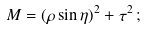Convert formula to latex. <formula><loc_0><loc_0><loc_500><loc_500>M = ( \rho \sin \eta ) ^ { 2 } + \tau ^ { 2 } \, ;</formula> 